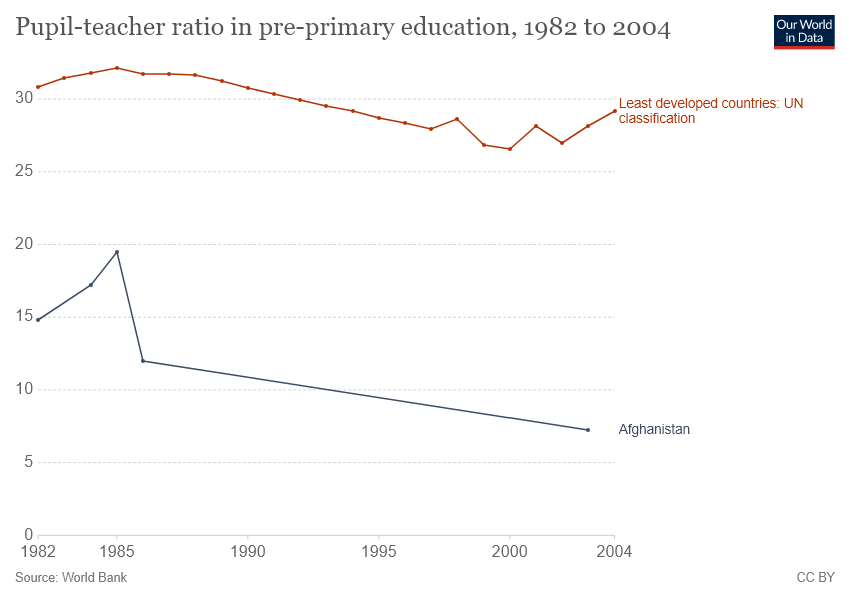Highlight a few significant elements in this photo. The country represented by the blue color line is Afghanistan. The highest pupil-teacher ratio in pre-primary education was recorded in Afghanistan in the year 1985. 